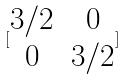<formula> <loc_0><loc_0><loc_500><loc_500>[ \begin{matrix} 3 / 2 & 0 \\ 0 & 3 / 2 \end{matrix} ]</formula> 